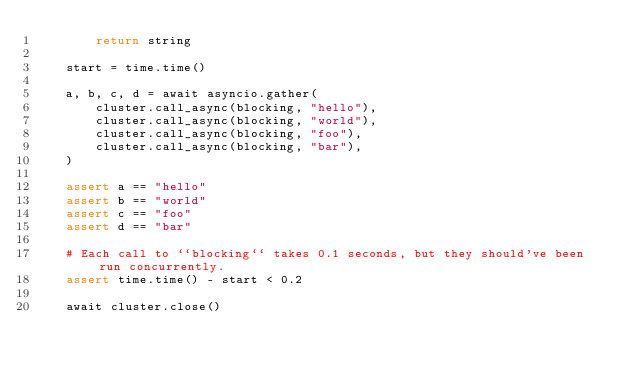<code> <loc_0><loc_0><loc_500><loc_500><_Python_>        return string

    start = time.time()

    a, b, c, d = await asyncio.gather(
        cluster.call_async(blocking, "hello"),
        cluster.call_async(blocking, "world"),
        cluster.call_async(blocking, "foo"),
        cluster.call_async(blocking, "bar"),
    )

    assert a == "hello"
    assert b == "world"
    assert c == "foo"
    assert d == "bar"

    # Each call to ``blocking`` takes 0.1 seconds, but they should've been run concurrently.
    assert time.time() - start < 0.2

    await cluster.close()
</code> 